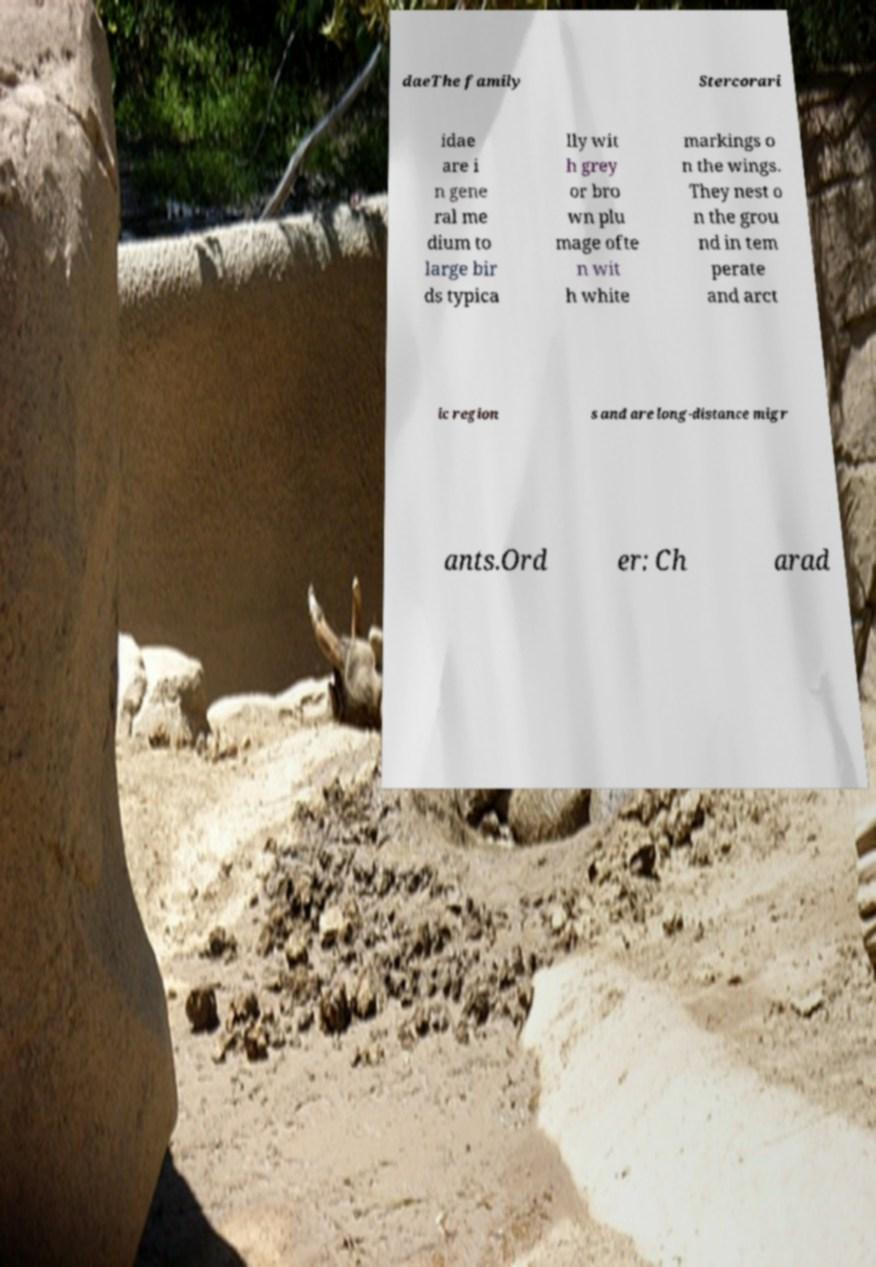There's text embedded in this image that I need extracted. Can you transcribe it verbatim? daeThe family Stercorari idae are i n gene ral me dium to large bir ds typica lly wit h grey or bro wn plu mage ofte n wit h white markings o n the wings. They nest o n the grou nd in tem perate and arct ic region s and are long-distance migr ants.Ord er: Ch arad 